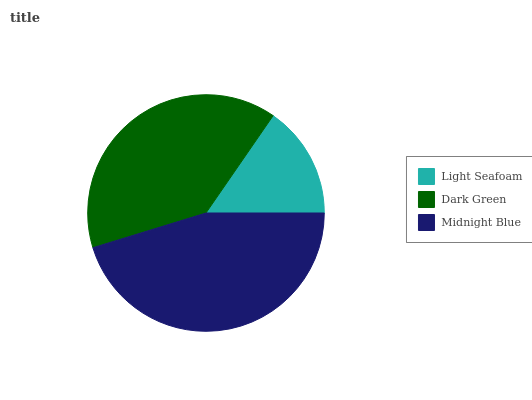Is Light Seafoam the minimum?
Answer yes or no. Yes. Is Midnight Blue the maximum?
Answer yes or no. Yes. Is Dark Green the minimum?
Answer yes or no. No. Is Dark Green the maximum?
Answer yes or no. No. Is Dark Green greater than Light Seafoam?
Answer yes or no. Yes. Is Light Seafoam less than Dark Green?
Answer yes or no. Yes. Is Light Seafoam greater than Dark Green?
Answer yes or no. No. Is Dark Green less than Light Seafoam?
Answer yes or no. No. Is Dark Green the high median?
Answer yes or no. Yes. Is Dark Green the low median?
Answer yes or no. Yes. Is Light Seafoam the high median?
Answer yes or no. No. Is Light Seafoam the low median?
Answer yes or no. No. 